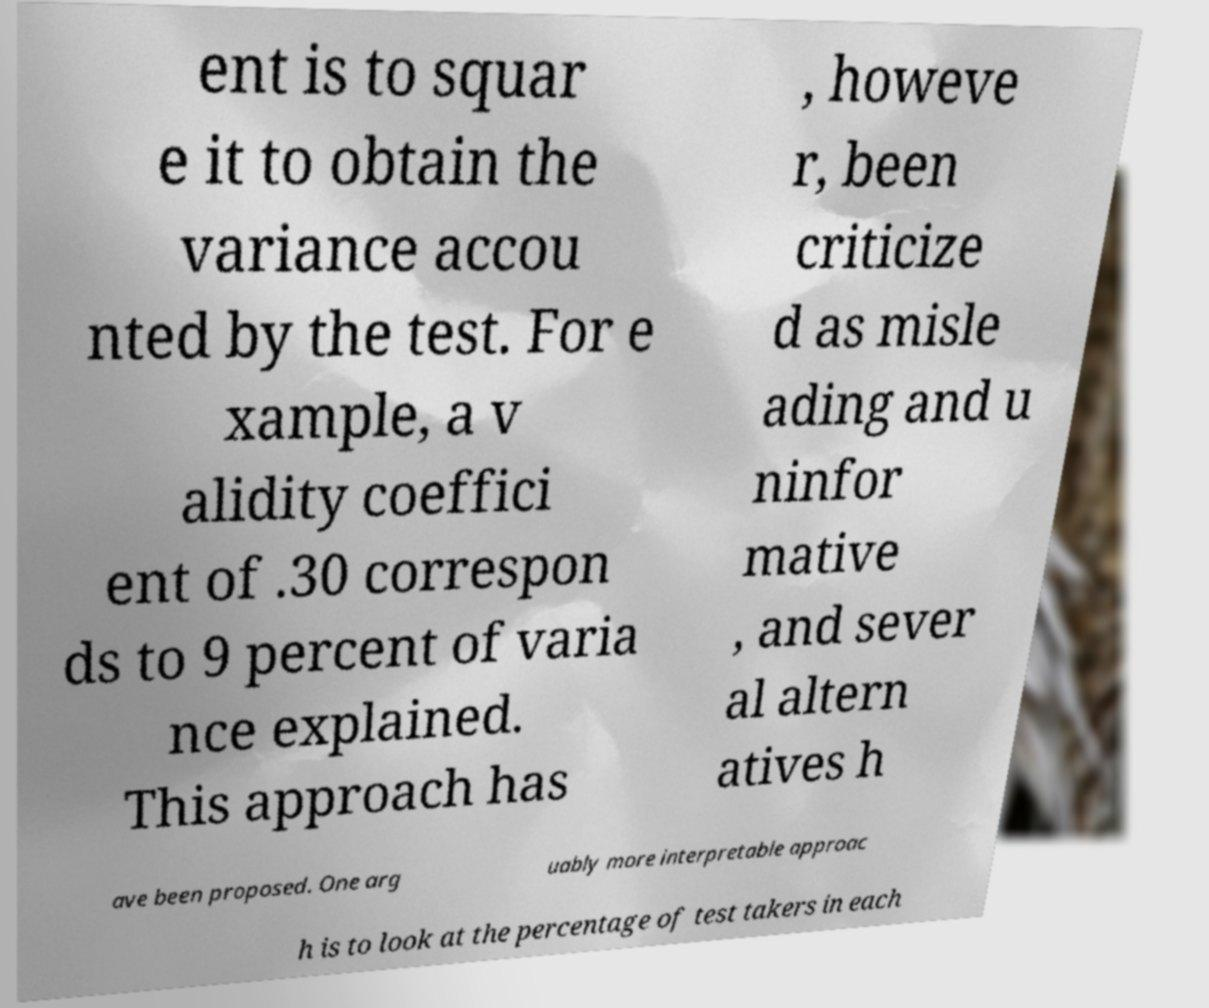Can you read and provide the text displayed in the image?This photo seems to have some interesting text. Can you extract and type it out for me? ent is to squar e it to obtain the variance accou nted by the test. For e xample, a v alidity coeffici ent of .30 correspon ds to 9 percent of varia nce explained. This approach has , howeve r, been criticize d as misle ading and u ninfor mative , and sever al altern atives h ave been proposed. One arg uably more interpretable approac h is to look at the percentage of test takers in each 